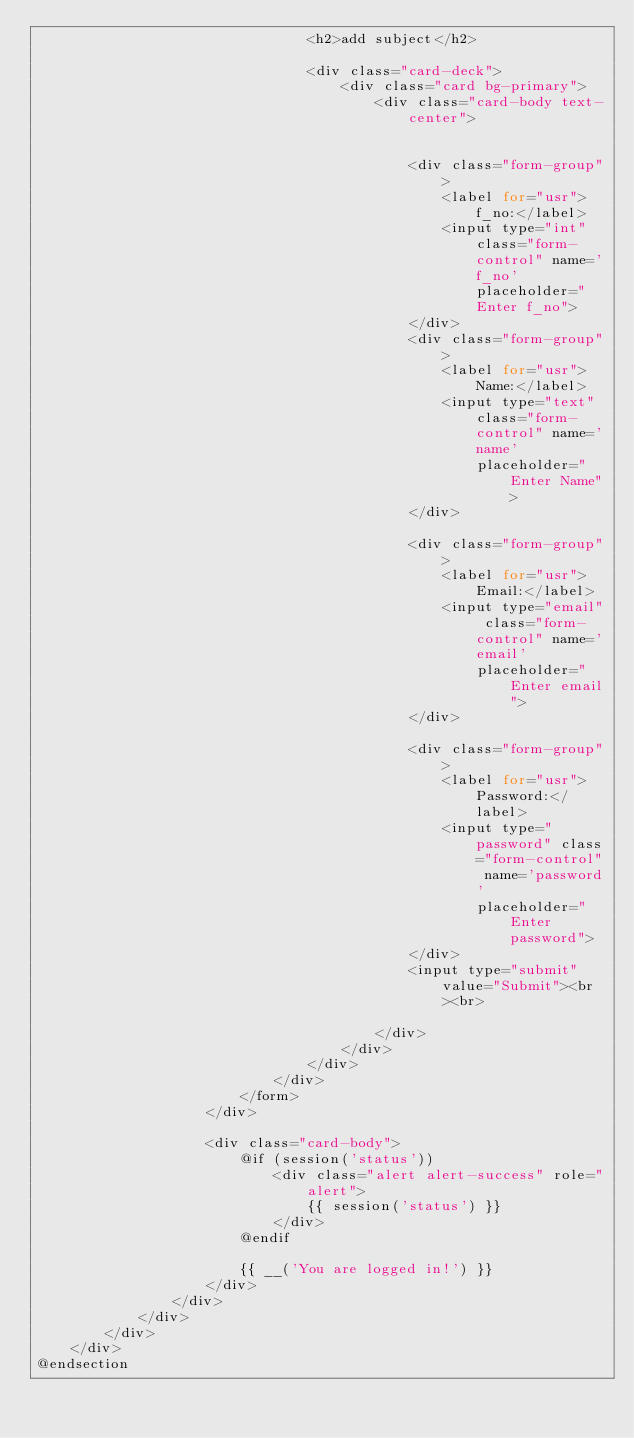Convert code to text. <code><loc_0><loc_0><loc_500><loc_500><_PHP_>                                <h2>add subject</h2>

                                <div class="card-deck">
                                    <div class="card bg-primary">
                                        <div class="card-body text-center">


                                            <div class="form-group">
                                                <label for="usr">f_no:</label>
                                                <input type="int" class="form-control" name='f_no' placeholder="Enter f_no">
                                            </div>
                                            <div class="form-group">
                                                <label for="usr">Name:</label>
                                                <input type="text" class="form-control" name='name'
                                                    placeholder="Enter Name">
                                            </div>

                                            <div class="form-group">
                                                <label for="usr">Email:</label>
                                                <input type="email" class="form-control" name='email'
                                                    placeholder="Enter email">
                                            </div>

                                            <div class="form-group">
                                                <label for="usr">Password:</label>
                                                <input type="password" class="form-control" name='password'
                                                    placeholder="Enter password">
                                            </div>
                                            <input type="submit" value="Submit"><br><br>

                                        </div>
                                    </div>
                                </div>
                            </div>
                        </form>
                    </div>

                    <div class="card-body">
                        @if (session('status'))
                            <div class="alert alert-success" role="alert">
                                {{ session('status') }}
                            </div>
                        @endif

                        {{ __('You are logged in!') }}
                    </div>
                </div>
            </div>
        </div>
    </div>
@endsection
</code> 